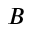<formula> <loc_0><loc_0><loc_500><loc_500>B</formula> 